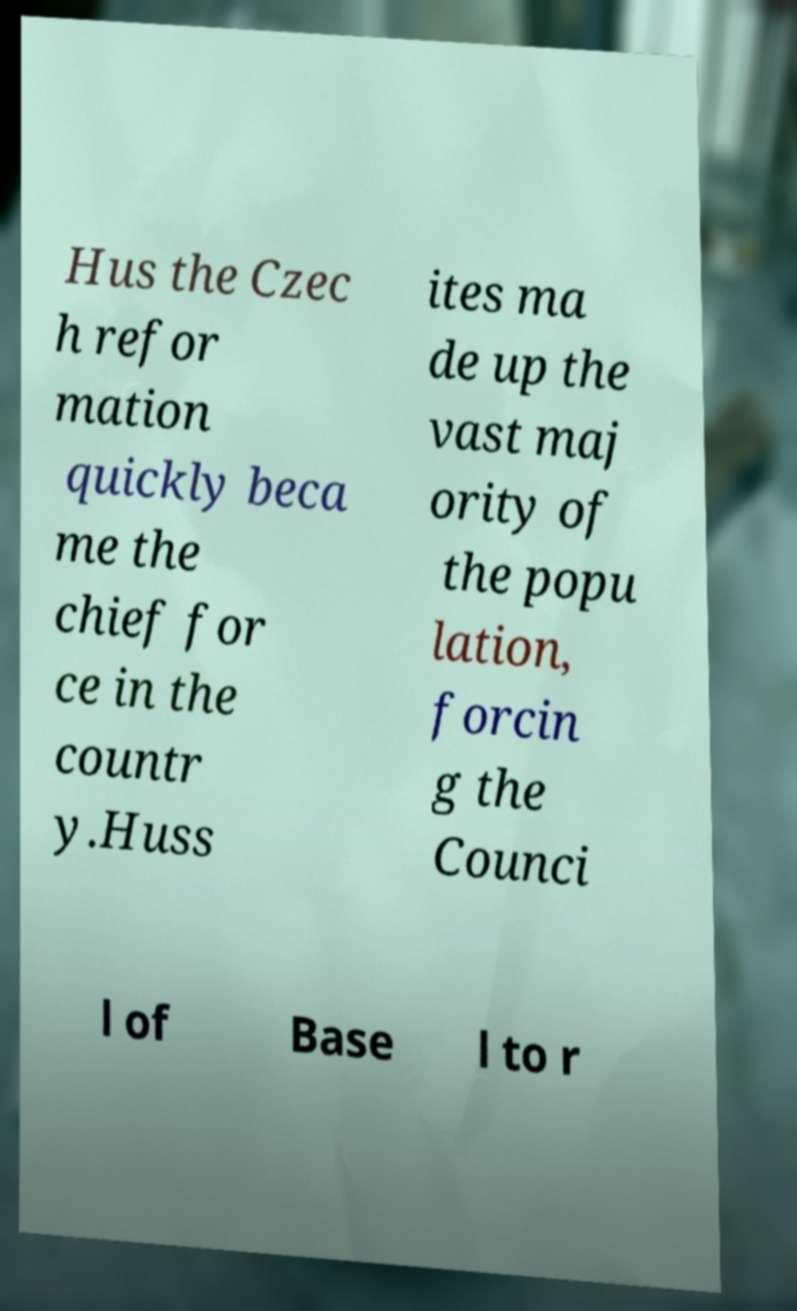Please read and relay the text visible in this image. What does it say? Hus the Czec h refor mation quickly beca me the chief for ce in the countr y.Huss ites ma de up the vast maj ority of the popu lation, forcin g the Counci l of Base l to r 